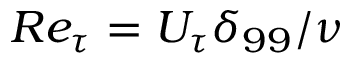<formula> <loc_0><loc_0><loc_500><loc_500>R e _ { \tau } = U _ { \tau } \delta _ { 9 9 } / \nu</formula> 